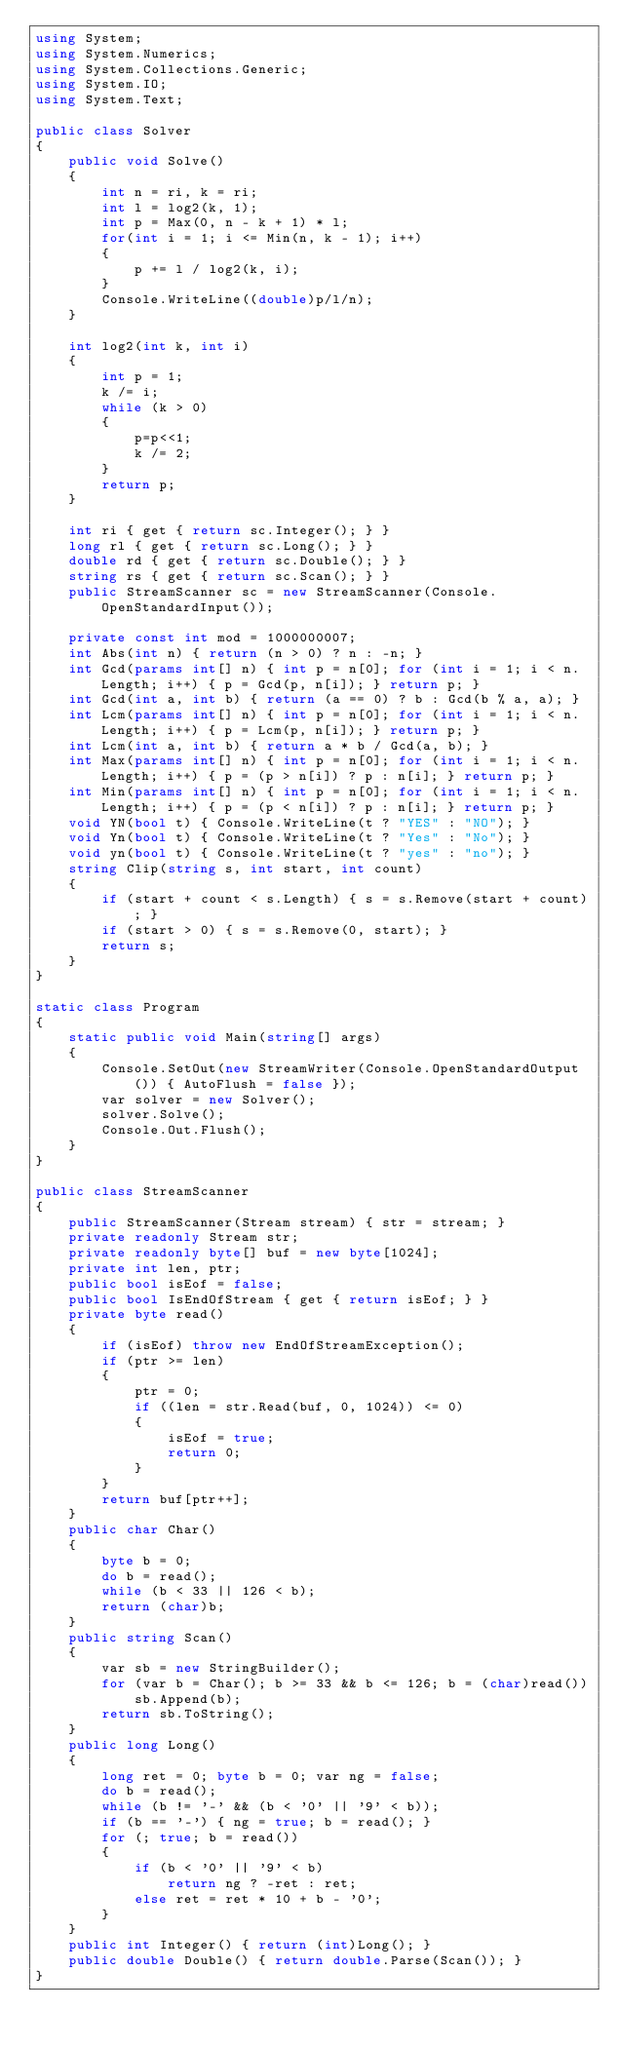<code> <loc_0><loc_0><loc_500><loc_500><_C#_>using System;
using System.Numerics;
using System.Collections.Generic;
using System.IO;
using System.Text;

public class Solver
{
    public void Solve()
    {
        int n = ri, k = ri;
        int l = log2(k, 1);
        int p = Max(0, n - k + 1) * l;
        for(int i = 1; i <= Min(n, k - 1); i++)
        {
            p += l / log2(k, i);
        }
        Console.WriteLine((double)p/l/n);
    }

    int log2(int k, int i)
    {
        int p = 1;
        k /= i;
        while (k > 0)
        {
            p=p<<1;
            k /= 2;
        }
        return p;
    }

    int ri { get { return sc.Integer(); } }
    long rl { get { return sc.Long(); } }
    double rd { get { return sc.Double(); } }
    string rs { get { return sc.Scan(); } }
    public StreamScanner sc = new StreamScanner(Console.OpenStandardInput());

    private const int mod = 1000000007;
    int Abs(int n) { return (n > 0) ? n : -n; }
    int Gcd(params int[] n) { int p = n[0]; for (int i = 1; i < n.Length; i++) { p = Gcd(p, n[i]); } return p; }
    int Gcd(int a, int b) { return (a == 0) ? b : Gcd(b % a, a); }
    int Lcm(params int[] n) { int p = n[0]; for (int i = 1; i < n.Length; i++) { p = Lcm(p, n[i]); } return p; }
    int Lcm(int a, int b) { return a * b / Gcd(a, b); }
    int Max(params int[] n) { int p = n[0]; for (int i = 1; i < n.Length; i++) { p = (p > n[i]) ? p : n[i]; } return p; }
    int Min(params int[] n) { int p = n[0]; for (int i = 1; i < n.Length; i++) { p = (p < n[i]) ? p : n[i]; } return p; }
    void YN(bool t) { Console.WriteLine(t ? "YES" : "NO"); }
    void Yn(bool t) { Console.WriteLine(t ? "Yes" : "No"); }
    void yn(bool t) { Console.WriteLine(t ? "yes" : "no"); }
    string Clip(string s, int start, int count)
    {
        if (start + count < s.Length) { s = s.Remove(start + count); }
        if (start > 0) { s = s.Remove(0, start); }
        return s;
    }
}

static class Program
{
    static public void Main(string[] args)
    {
        Console.SetOut(new StreamWriter(Console.OpenStandardOutput()) { AutoFlush = false });
        var solver = new Solver();
        solver.Solve();
        Console.Out.Flush();
    }
}

public class StreamScanner
{
    public StreamScanner(Stream stream) { str = stream; }
    private readonly Stream str;
    private readonly byte[] buf = new byte[1024];
    private int len, ptr;
    public bool isEof = false;
    public bool IsEndOfStream { get { return isEof; } }
    private byte read()
    {
        if (isEof) throw new EndOfStreamException();
        if (ptr >= len)
        {
            ptr = 0;
            if ((len = str.Read(buf, 0, 1024)) <= 0)
            {
                isEof = true;
                return 0;
            }
        }
        return buf[ptr++];
    }
    public char Char()
    {
        byte b = 0;
        do b = read();
        while (b < 33 || 126 < b);
        return (char)b;
    }
    public string Scan()
    {
        var sb = new StringBuilder();
        for (var b = Char(); b >= 33 && b <= 126; b = (char)read())
            sb.Append(b);
        return sb.ToString();
    }
    public long Long()
    {
        long ret = 0; byte b = 0; var ng = false;
        do b = read();
        while (b != '-' && (b < '0' || '9' < b));
        if (b == '-') { ng = true; b = read(); }
        for (; true; b = read())
        {
            if (b < '0' || '9' < b)
                return ng ? -ret : ret;
            else ret = ret * 10 + b - '0';
        }
    }
    public int Integer() { return (int)Long(); }
    public double Double() { return double.Parse(Scan()); }
}</code> 